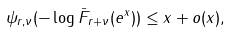Convert formula to latex. <formula><loc_0><loc_0><loc_500><loc_500>\psi _ { r , \nu } ( - \log \bar { F } _ { r + \nu } ( e ^ { x } ) ) \leq x + o ( x ) ,</formula> 